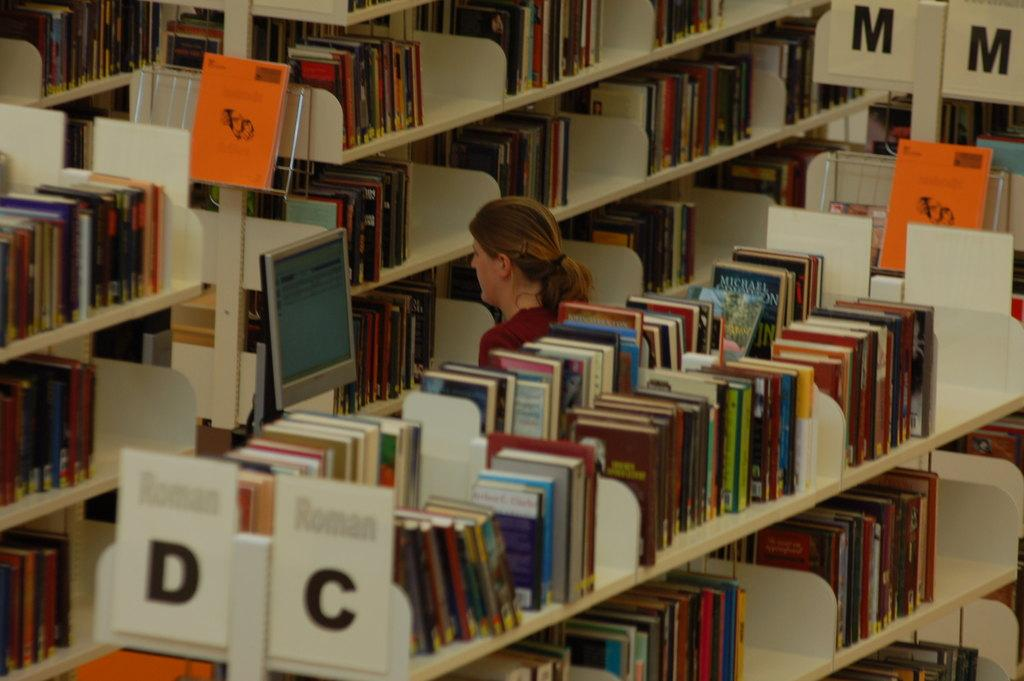<image>
Offer a succinct explanation of the picture presented. A woman looks at books in a library system near place holders C and D and M. 